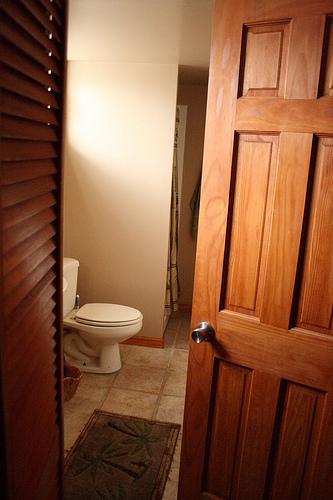What material was the door made from?
Be succinct. Wood. Where is the door leading to?
Concise answer only. Bathroom. Is someone using the bathroom?
Quick response, please. No. 